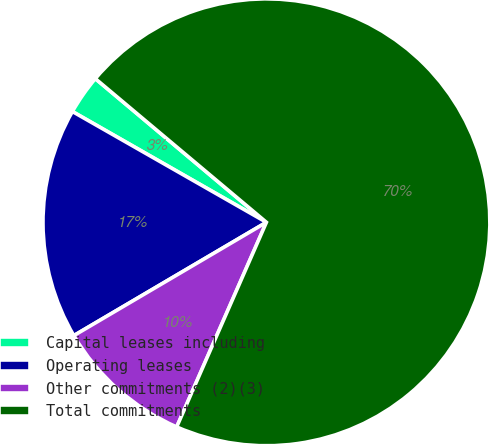Convert chart to OTSL. <chart><loc_0><loc_0><loc_500><loc_500><pie_chart><fcel>Capital leases including<fcel>Operating leases<fcel>Other commitments (2)(3)<fcel>Total commitments<nl><fcel>2.86%<fcel>16.72%<fcel>9.96%<fcel>70.46%<nl></chart> 